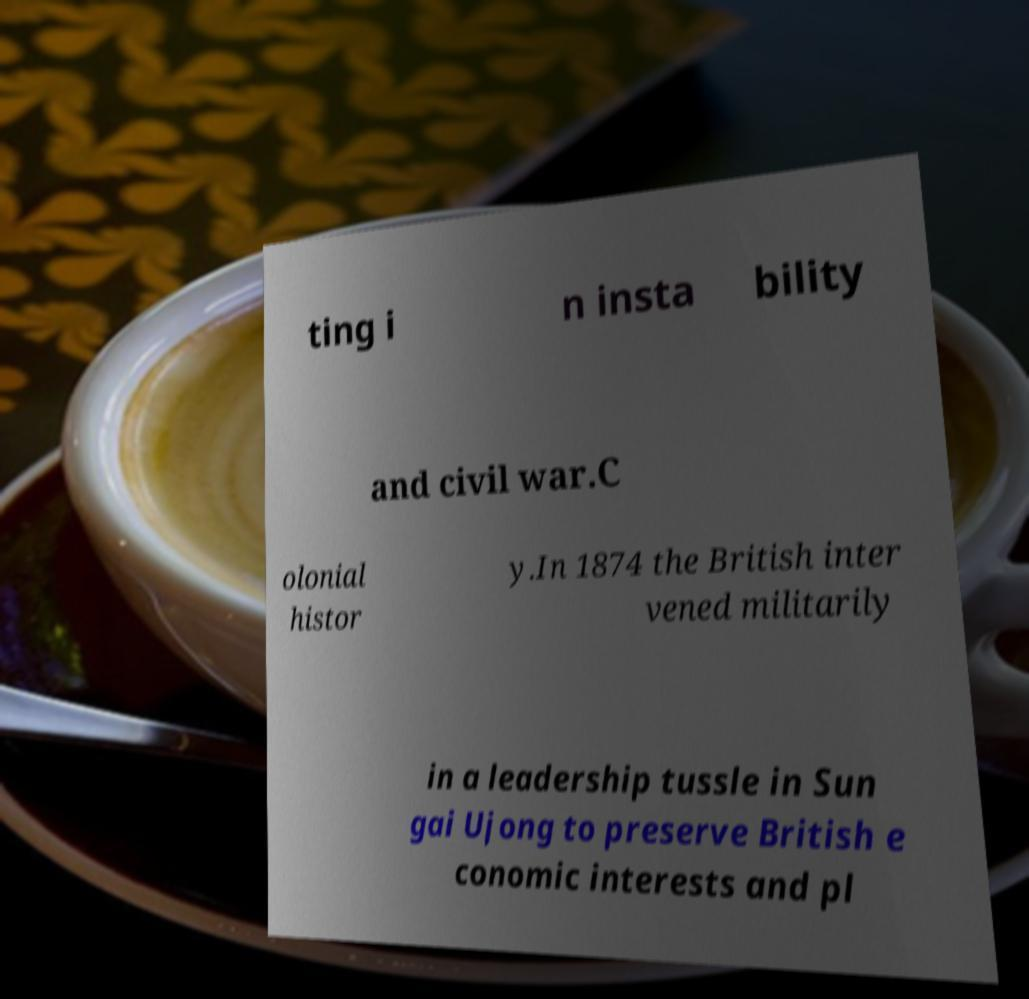There's text embedded in this image that I need extracted. Can you transcribe it verbatim? ting i n insta bility and civil war.C olonial histor y.In 1874 the British inter vened militarily in a leadership tussle in Sun gai Ujong to preserve British e conomic interests and pl 